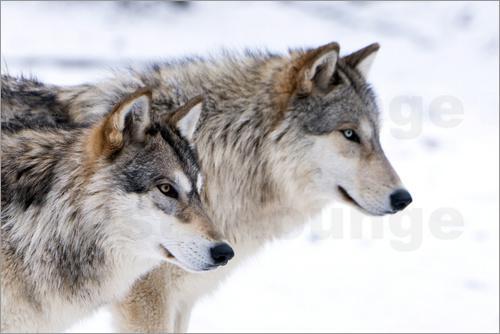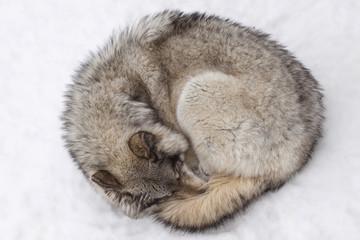The first image is the image on the left, the second image is the image on the right. Analyze the images presented: Is the assertion "One image contains two wolves standing up, and the other contains one wolf sleeping peacefully." valid? Answer yes or no. Yes. The first image is the image on the left, the second image is the image on the right. Assess this claim about the two images: "One image shows two awake, open-eyed wolves posed close together and similarly.". Correct or not? Answer yes or no. Yes. 